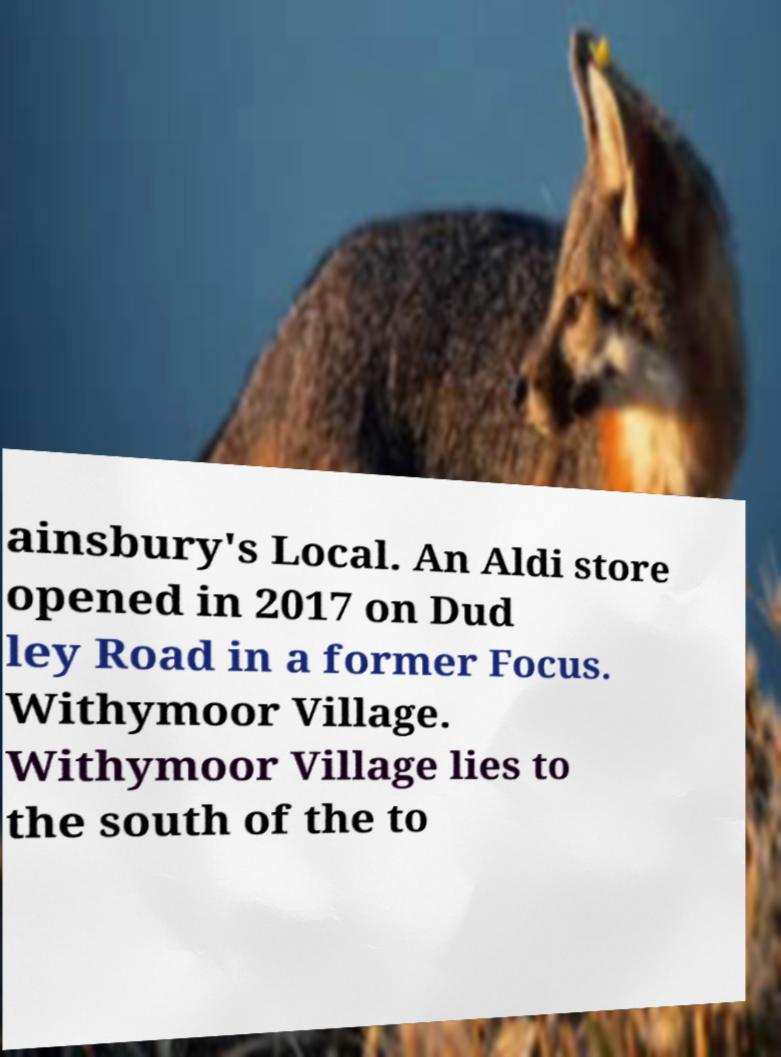Could you extract and type out the text from this image? ainsbury's Local. An Aldi store opened in 2017 on Dud ley Road in a former Focus. Withymoor Village. Withymoor Village lies to the south of the to 